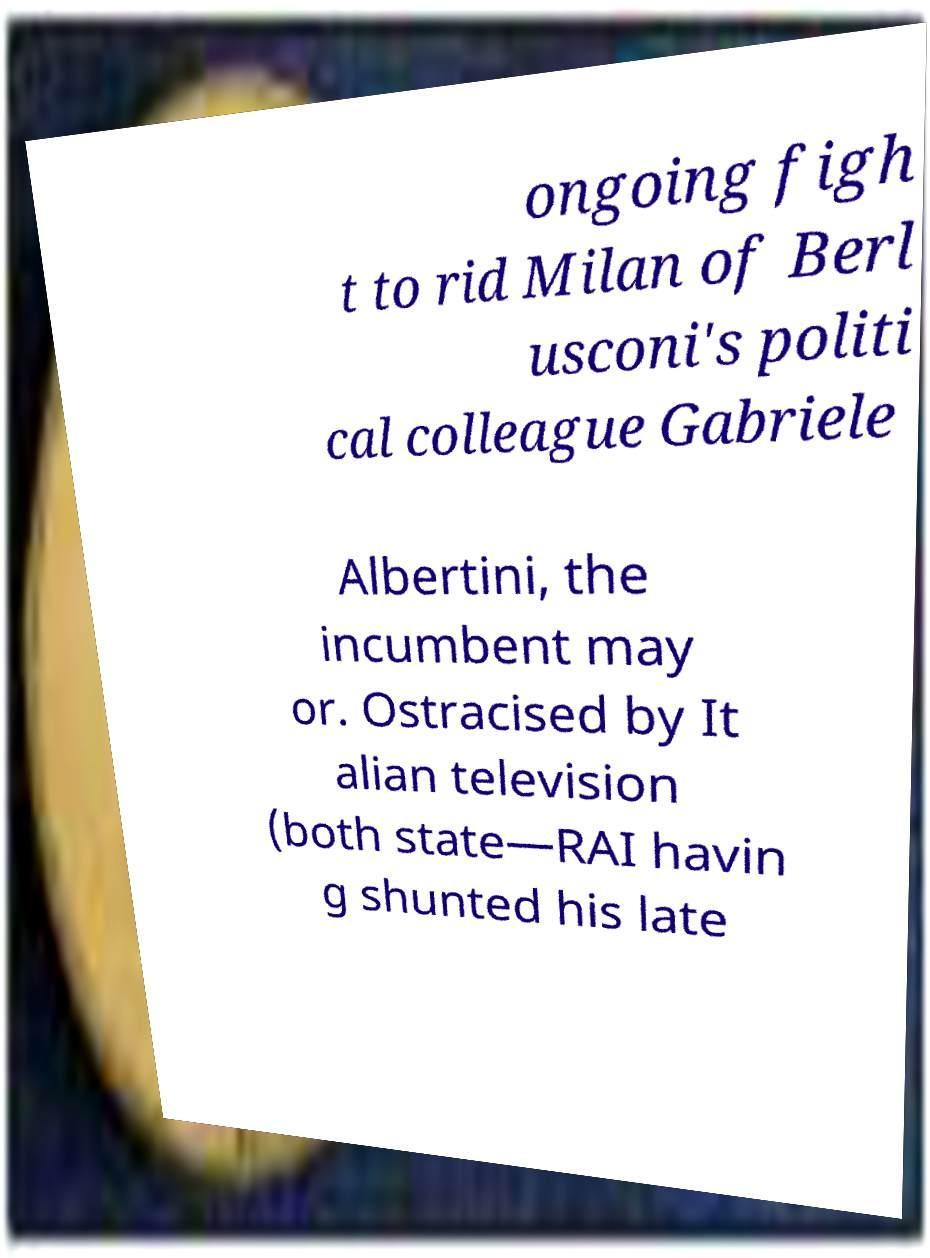I need the written content from this picture converted into text. Can you do that? ongoing figh t to rid Milan of Berl usconi's politi cal colleague Gabriele Albertini, the incumbent may or. Ostracised by It alian television (both state—RAI havin g shunted his late 